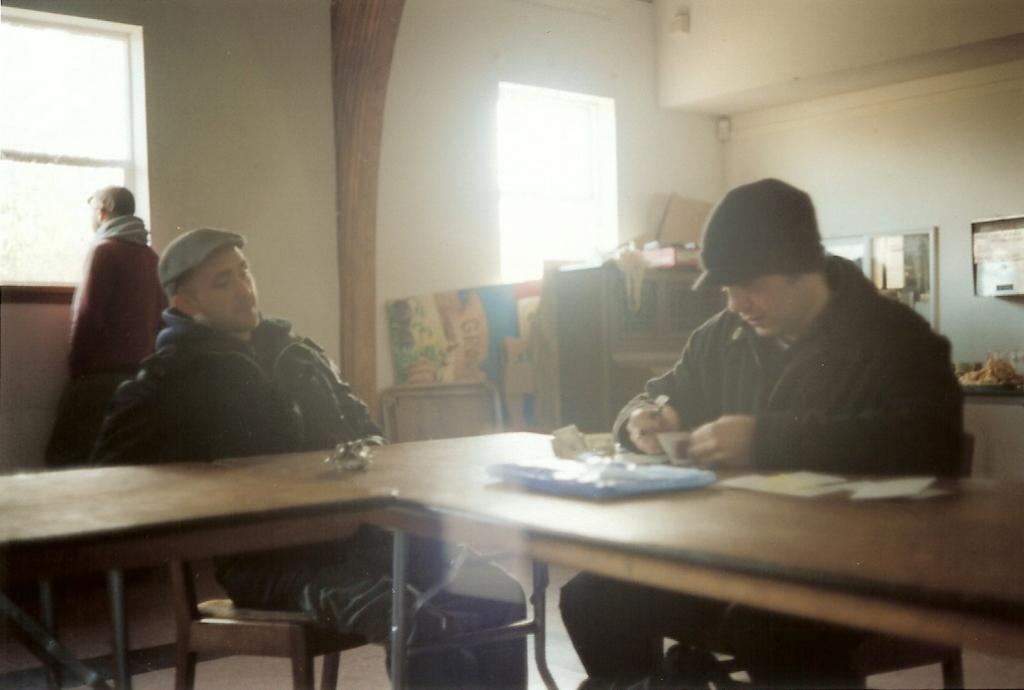How many people are in the image? There are three persons in the image. What are two of the persons doing in the image? Two of the persons are sitting on chairs. What is the third person doing in the image? The third person is looking outside through a window. What type of ornament is hanging from the ceiling in the image? There is no ornament hanging from the ceiling in the image. How does the turkey contribute to the conversation in the image? There is no turkey present in the image, so it cannot contribute to the conversation. 